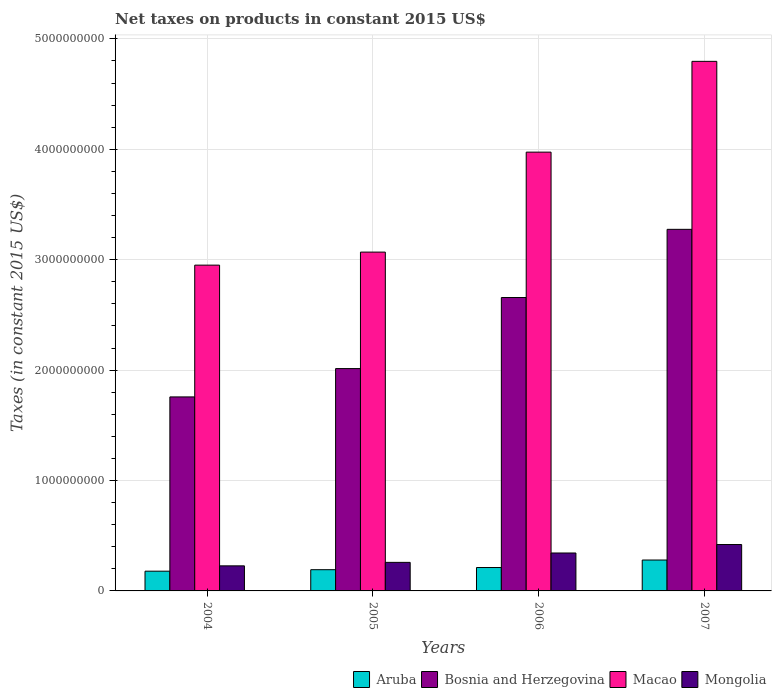How many bars are there on the 1st tick from the left?
Provide a short and direct response. 4. How many bars are there on the 4th tick from the right?
Ensure brevity in your answer.  4. What is the label of the 2nd group of bars from the left?
Your answer should be very brief. 2005. What is the net taxes on products in Macao in 2007?
Ensure brevity in your answer.  4.80e+09. Across all years, what is the maximum net taxes on products in Macao?
Offer a very short reply. 4.80e+09. Across all years, what is the minimum net taxes on products in Mongolia?
Provide a short and direct response. 2.27e+08. In which year was the net taxes on products in Mongolia maximum?
Your answer should be compact. 2007. What is the total net taxes on products in Aruba in the graph?
Provide a succinct answer. 8.63e+08. What is the difference between the net taxes on products in Aruba in 2004 and that in 2005?
Offer a terse response. -1.34e+07. What is the difference between the net taxes on products in Aruba in 2005 and the net taxes on products in Mongolia in 2006?
Give a very brief answer. -1.51e+08. What is the average net taxes on products in Macao per year?
Make the answer very short. 3.70e+09. In the year 2005, what is the difference between the net taxes on products in Mongolia and net taxes on products in Macao?
Offer a very short reply. -2.81e+09. In how many years, is the net taxes on products in Bosnia and Herzegovina greater than 1400000000 US$?
Provide a short and direct response. 4. What is the ratio of the net taxes on products in Bosnia and Herzegovina in 2005 to that in 2007?
Your response must be concise. 0.61. What is the difference between the highest and the second highest net taxes on products in Aruba?
Offer a terse response. 6.79e+07. What is the difference between the highest and the lowest net taxes on products in Bosnia and Herzegovina?
Offer a very short reply. 1.52e+09. Is it the case that in every year, the sum of the net taxes on products in Bosnia and Herzegovina and net taxes on products in Aruba is greater than the sum of net taxes on products in Macao and net taxes on products in Mongolia?
Ensure brevity in your answer.  No. What does the 3rd bar from the left in 2006 represents?
Make the answer very short. Macao. What does the 2nd bar from the right in 2006 represents?
Your answer should be compact. Macao. Does the graph contain any zero values?
Your response must be concise. No. Does the graph contain grids?
Ensure brevity in your answer.  Yes. How many legend labels are there?
Ensure brevity in your answer.  4. How are the legend labels stacked?
Your answer should be very brief. Horizontal. What is the title of the graph?
Your answer should be very brief. Net taxes on products in constant 2015 US$. What is the label or title of the X-axis?
Offer a very short reply. Years. What is the label or title of the Y-axis?
Give a very brief answer. Taxes (in constant 2015 US$). What is the Taxes (in constant 2015 US$) of Aruba in 2004?
Offer a very short reply. 1.79e+08. What is the Taxes (in constant 2015 US$) in Bosnia and Herzegovina in 2004?
Provide a short and direct response. 1.76e+09. What is the Taxes (in constant 2015 US$) of Macao in 2004?
Ensure brevity in your answer.  2.95e+09. What is the Taxes (in constant 2015 US$) of Mongolia in 2004?
Provide a succinct answer. 2.27e+08. What is the Taxes (in constant 2015 US$) in Aruba in 2005?
Ensure brevity in your answer.  1.92e+08. What is the Taxes (in constant 2015 US$) in Bosnia and Herzegovina in 2005?
Ensure brevity in your answer.  2.01e+09. What is the Taxes (in constant 2015 US$) in Macao in 2005?
Give a very brief answer. 3.07e+09. What is the Taxes (in constant 2015 US$) of Mongolia in 2005?
Your answer should be compact. 2.59e+08. What is the Taxes (in constant 2015 US$) in Aruba in 2006?
Give a very brief answer. 2.12e+08. What is the Taxes (in constant 2015 US$) of Bosnia and Herzegovina in 2006?
Keep it short and to the point. 2.66e+09. What is the Taxes (in constant 2015 US$) of Macao in 2006?
Provide a short and direct response. 3.97e+09. What is the Taxes (in constant 2015 US$) in Mongolia in 2006?
Provide a succinct answer. 3.44e+08. What is the Taxes (in constant 2015 US$) in Aruba in 2007?
Make the answer very short. 2.80e+08. What is the Taxes (in constant 2015 US$) in Bosnia and Herzegovina in 2007?
Provide a succinct answer. 3.28e+09. What is the Taxes (in constant 2015 US$) of Macao in 2007?
Provide a succinct answer. 4.80e+09. What is the Taxes (in constant 2015 US$) of Mongolia in 2007?
Offer a very short reply. 4.20e+08. Across all years, what is the maximum Taxes (in constant 2015 US$) of Aruba?
Offer a very short reply. 2.80e+08. Across all years, what is the maximum Taxes (in constant 2015 US$) of Bosnia and Herzegovina?
Give a very brief answer. 3.28e+09. Across all years, what is the maximum Taxes (in constant 2015 US$) in Macao?
Keep it short and to the point. 4.80e+09. Across all years, what is the maximum Taxes (in constant 2015 US$) of Mongolia?
Provide a succinct answer. 4.20e+08. Across all years, what is the minimum Taxes (in constant 2015 US$) of Aruba?
Give a very brief answer. 1.79e+08. Across all years, what is the minimum Taxes (in constant 2015 US$) of Bosnia and Herzegovina?
Provide a short and direct response. 1.76e+09. Across all years, what is the minimum Taxes (in constant 2015 US$) of Macao?
Offer a very short reply. 2.95e+09. Across all years, what is the minimum Taxes (in constant 2015 US$) in Mongolia?
Your answer should be compact. 2.27e+08. What is the total Taxes (in constant 2015 US$) of Aruba in the graph?
Provide a succinct answer. 8.63e+08. What is the total Taxes (in constant 2015 US$) in Bosnia and Herzegovina in the graph?
Ensure brevity in your answer.  9.70e+09. What is the total Taxes (in constant 2015 US$) of Macao in the graph?
Give a very brief answer. 1.48e+1. What is the total Taxes (in constant 2015 US$) of Mongolia in the graph?
Your answer should be very brief. 1.25e+09. What is the difference between the Taxes (in constant 2015 US$) of Aruba in 2004 and that in 2005?
Provide a succinct answer. -1.34e+07. What is the difference between the Taxes (in constant 2015 US$) in Bosnia and Herzegovina in 2004 and that in 2005?
Provide a short and direct response. -2.57e+08. What is the difference between the Taxes (in constant 2015 US$) in Macao in 2004 and that in 2005?
Your response must be concise. -1.18e+08. What is the difference between the Taxes (in constant 2015 US$) in Mongolia in 2004 and that in 2005?
Your answer should be very brief. -3.15e+07. What is the difference between the Taxes (in constant 2015 US$) in Aruba in 2004 and that in 2006?
Make the answer very short. -3.31e+07. What is the difference between the Taxes (in constant 2015 US$) in Bosnia and Herzegovina in 2004 and that in 2006?
Make the answer very short. -9.00e+08. What is the difference between the Taxes (in constant 2015 US$) in Macao in 2004 and that in 2006?
Keep it short and to the point. -1.02e+09. What is the difference between the Taxes (in constant 2015 US$) in Mongolia in 2004 and that in 2006?
Offer a terse response. -1.16e+08. What is the difference between the Taxes (in constant 2015 US$) in Aruba in 2004 and that in 2007?
Offer a terse response. -1.01e+08. What is the difference between the Taxes (in constant 2015 US$) in Bosnia and Herzegovina in 2004 and that in 2007?
Keep it short and to the point. -1.52e+09. What is the difference between the Taxes (in constant 2015 US$) of Macao in 2004 and that in 2007?
Your answer should be very brief. -1.85e+09. What is the difference between the Taxes (in constant 2015 US$) in Mongolia in 2004 and that in 2007?
Ensure brevity in your answer.  -1.93e+08. What is the difference between the Taxes (in constant 2015 US$) in Aruba in 2005 and that in 2006?
Provide a succinct answer. -1.97e+07. What is the difference between the Taxes (in constant 2015 US$) in Bosnia and Herzegovina in 2005 and that in 2006?
Offer a terse response. -6.44e+08. What is the difference between the Taxes (in constant 2015 US$) in Macao in 2005 and that in 2006?
Ensure brevity in your answer.  -9.06e+08. What is the difference between the Taxes (in constant 2015 US$) in Mongolia in 2005 and that in 2006?
Keep it short and to the point. -8.49e+07. What is the difference between the Taxes (in constant 2015 US$) of Aruba in 2005 and that in 2007?
Your answer should be very brief. -8.76e+07. What is the difference between the Taxes (in constant 2015 US$) in Bosnia and Herzegovina in 2005 and that in 2007?
Offer a terse response. -1.26e+09. What is the difference between the Taxes (in constant 2015 US$) in Macao in 2005 and that in 2007?
Provide a short and direct response. -1.73e+09. What is the difference between the Taxes (in constant 2015 US$) of Mongolia in 2005 and that in 2007?
Give a very brief answer. -1.62e+08. What is the difference between the Taxes (in constant 2015 US$) of Aruba in 2006 and that in 2007?
Offer a terse response. -6.79e+07. What is the difference between the Taxes (in constant 2015 US$) of Bosnia and Herzegovina in 2006 and that in 2007?
Provide a short and direct response. -6.18e+08. What is the difference between the Taxes (in constant 2015 US$) of Macao in 2006 and that in 2007?
Ensure brevity in your answer.  -8.22e+08. What is the difference between the Taxes (in constant 2015 US$) of Mongolia in 2006 and that in 2007?
Keep it short and to the point. -7.67e+07. What is the difference between the Taxes (in constant 2015 US$) in Aruba in 2004 and the Taxes (in constant 2015 US$) in Bosnia and Herzegovina in 2005?
Your answer should be compact. -1.84e+09. What is the difference between the Taxes (in constant 2015 US$) in Aruba in 2004 and the Taxes (in constant 2015 US$) in Macao in 2005?
Your answer should be compact. -2.89e+09. What is the difference between the Taxes (in constant 2015 US$) in Aruba in 2004 and the Taxes (in constant 2015 US$) in Mongolia in 2005?
Provide a succinct answer. -7.99e+07. What is the difference between the Taxes (in constant 2015 US$) of Bosnia and Herzegovina in 2004 and the Taxes (in constant 2015 US$) of Macao in 2005?
Give a very brief answer. -1.31e+09. What is the difference between the Taxes (in constant 2015 US$) in Bosnia and Herzegovina in 2004 and the Taxes (in constant 2015 US$) in Mongolia in 2005?
Offer a terse response. 1.50e+09. What is the difference between the Taxes (in constant 2015 US$) of Macao in 2004 and the Taxes (in constant 2015 US$) of Mongolia in 2005?
Make the answer very short. 2.69e+09. What is the difference between the Taxes (in constant 2015 US$) of Aruba in 2004 and the Taxes (in constant 2015 US$) of Bosnia and Herzegovina in 2006?
Keep it short and to the point. -2.48e+09. What is the difference between the Taxes (in constant 2015 US$) of Aruba in 2004 and the Taxes (in constant 2015 US$) of Macao in 2006?
Keep it short and to the point. -3.80e+09. What is the difference between the Taxes (in constant 2015 US$) in Aruba in 2004 and the Taxes (in constant 2015 US$) in Mongolia in 2006?
Keep it short and to the point. -1.65e+08. What is the difference between the Taxes (in constant 2015 US$) of Bosnia and Herzegovina in 2004 and the Taxes (in constant 2015 US$) of Macao in 2006?
Your response must be concise. -2.22e+09. What is the difference between the Taxes (in constant 2015 US$) of Bosnia and Herzegovina in 2004 and the Taxes (in constant 2015 US$) of Mongolia in 2006?
Keep it short and to the point. 1.41e+09. What is the difference between the Taxes (in constant 2015 US$) of Macao in 2004 and the Taxes (in constant 2015 US$) of Mongolia in 2006?
Make the answer very short. 2.61e+09. What is the difference between the Taxes (in constant 2015 US$) of Aruba in 2004 and the Taxes (in constant 2015 US$) of Bosnia and Herzegovina in 2007?
Give a very brief answer. -3.10e+09. What is the difference between the Taxes (in constant 2015 US$) in Aruba in 2004 and the Taxes (in constant 2015 US$) in Macao in 2007?
Make the answer very short. -4.62e+09. What is the difference between the Taxes (in constant 2015 US$) of Aruba in 2004 and the Taxes (in constant 2015 US$) of Mongolia in 2007?
Provide a succinct answer. -2.41e+08. What is the difference between the Taxes (in constant 2015 US$) in Bosnia and Herzegovina in 2004 and the Taxes (in constant 2015 US$) in Macao in 2007?
Offer a terse response. -3.04e+09. What is the difference between the Taxes (in constant 2015 US$) of Bosnia and Herzegovina in 2004 and the Taxes (in constant 2015 US$) of Mongolia in 2007?
Give a very brief answer. 1.34e+09. What is the difference between the Taxes (in constant 2015 US$) in Macao in 2004 and the Taxes (in constant 2015 US$) in Mongolia in 2007?
Your answer should be compact. 2.53e+09. What is the difference between the Taxes (in constant 2015 US$) of Aruba in 2005 and the Taxes (in constant 2015 US$) of Bosnia and Herzegovina in 2006?
Your answer should be very brief. -2.47e+09. What is the difference between the Taxes (in constant 2015 US$) of Aruba in 2005 and the Taxes (in constant 2015 US$) of Macao in 2006?
Your answer should be compact. -3.78e+09. What is the difference between the Taxes (in constant 2015 US$) of Aruba in 2005 and the Taxes (in constant 2015 US$) of Mongolia in 2006?
Offer a terse response. -1.51e+08. What is the difference between the Taxes (in constant 2015 US$) in Bosnia and Herzegovina in 2005 and the Taxes (in constant 2015 US$) in Macao in 2006?
Keep it short and to the point. -1.96e+09. What is the difference between the Taxes (in constant 2015 US$) of Bosnia and Herzegovina in 2005 and the Taxes (in constant 2015 US$) of Mongolia in 2006?
Offer a terse response. 1.67e+09. What is the difference between the Taxes (in constant 2015 US$) of Macao in 2005 and the Taxes (in constant 2015 US$) of Mongolia in 2006?
Offer a terse response. 2.73e+09. What is the difference between the Taxes (in constant 2015 US$) of Aruba in 2005 and the Taxes (in constant 2015 US$) of Bosnia and Herzegovina in 2007?
Give a very brief answer. -3.08e+09. What is the difference between the Taxes (in constant 2015 US$) of Aruba in 2005 and the Taxes (in constant 2015 US$) of Macao in 2007?
Keep it short and to the point. -4.60e+09. What is the difference between the Taxes (in constant 2015 US$) in Aruba in 2005 and the Taxes (in constant 2015 US$) in Mongolia in 2007?
Your response must be concise. -2.28e+08. What is the difference between the Taxes (in constant 2015 US$) in Bosnia and Herzegovina in 2005 and the Taxes (in constant 2015 US$) in Macao in 2007?
Your answer should be compact. -2.78e+09. What is the difference between the Taxes (in constant 2015 US$) of Bosnia and Herzegovina in 2005 and the Taxes (in constant 2015 US$) of Mongolia in 2007?
Provide a succinct answer. 1.59e+09. What is the difference between the Taxes (in constant 2015 US$) of Macao in 2005 and the Taxes (in constant 2015 US$) of Mongolia in 2007?
Your answer should be compact. 2.65e+09. What is the difference between the Taxes (in constant 2015 US$) in Aruba in 2006 and the Taxes (in constant 2015 US$) in Bosnia and Herzegovina in 2007?
Give a very brief answer. -3.06e+09. What is the difference between the Taxes (in constant 2015 US$) of Aruba in 2006 and the Taxes (in constant 2015 US$) of Macao in 2007?
Provide a short and direct response. -4.58e+09. What is the difference between the Taxes (in constant 2015 US$) in Aruba in 2006 and the Taxes (in constant 2015 US$) in Mongolia in 2007?
Ensure brevity in your answer.  -2.08e+08. What is the difference between the Taxes (in constant 2015 US$) of Bosnia and Herzegovina in 2006 and the Taxes (in constant 2015 US$) of Macao in 2007?
Your response must be concise. -2.14e+09. What is the difference between the Taxes (in constant 2015 US$) in Bosnia and Herzegovina in 2006 and the Taxes (in constant 2015 US$) in Mongolia in 2007?
Ensure brevity in your answer.  2.24e+09. What is the difference between the Taxes (in constant 2015 US$) in Macao in 2006 and the Taxes (in constant 2015 US$) in Mongolia in 2007?
Offer a very short reply. 3.55e+09. What is the average Taxes (in constant 2015 US$) of Aruba per year?
Your answer should be compact. 2.16e+08. What is the average Taxes (in constant 2015 US$) of Bosnia and Herzegovina per year?
Your answer should be compact. 2.43e+09. What is the average Taxes (in constant 2015 US$) of Macao per year?
Keep it short and to the point. 3.70e+09. What is the average Taxes (in constant 2015 US$) in Mongolia per year?
Your response must be concise. 3.12e+08. In the year 2004, what is the difference between the Taxes (in constant 2015 US$) in Aruba and Taxes (in constant 2015 US$) in Bosnia and Herzegovina?
Provide a succinct answer. -1.58e+09. In the year 2004, what is the difference between the Taxes (in constant 2015 US$) of Aruba and Taxes (in constant 2015 US$) of Macao?
Keep it short and to the point. -2.77e+09. In the year 2004, what is the difference between the Taxes (in constant 2015 US$) of Aruba and Taxes (in constant 2015 US$) of Mongolia?
Keep it short and to the point. -4.83e+07. In the year 2004, what is the difference between the Taxes (in constant 2015 US$) of Bosnia and Herzegovina and Taxes (in constant 2015 US$) of Macao?
Offer a terse response. -1.19e+09. In the year 2004, what is the difference between the Taxes (in constant 2015 US$) in Bosnia and Herzegovina and Taxes (in constant 2015 US$) in Mongolia?
Your answer should be very brief. 1.53e+09. In the year 2004, what is the difference between the Taxes (in constant 2015 US$) in Macao and Taxes (in constant 2015 US$) in Mongolia?
Provide a succinct answer. 2.72e+09. In the year 2005, what is the difference between the Taxes (in constant 2015 US$) in Aruba and Taxes (in constant 2015 US$) in Bosnia and Herzegovina?
Provide a short and direct response. -1.82e+09. In the year 2005, what is the difference between the Taxes (in constant 2015 US$) in Aruba and Taxes (in constant 2015 US$) in Macao?
Offer a very short reply. -2.88e+09. In the year 2005, what is the difference between the Taxes (in constant 2015 US$) in Aruba and Taxes (in constant 2015 US$) in Mongolia?
Offer a very short reply. -6.64e+07. In the year 2005, what is the difference between the Taxes (in constant 2015 US$) of Bosnia and Herzegovina and Taxes (in constant 2015 US$) of Macao?
Provide a short and direct response. -1.06e+09. In the year 2005, what is the difference between the Taxes (in constant 2015 US$) in Bosnia and Herzegovina and Taxes (in constant 2015 US$) in Mongolia?
Provide a succinct answer. 1.76e+09. In the year 2005, what is the difference between the Taxes (in constant 2015 US$) in Macao and Taxes (in constant 2015 US$) in Mongolia?
Your answer should be very brief. 2.81e+09. In the year 2006, what is the difference between the Taxes (in constant 2015 US$) of Aruba and Taxes (in constant 2015 US$) of Bosnia and Herzegovina?
Make the answer very short. -2.45e+09. In the year 2006, what is the difference between the Taxes (in constant 2015 US$) in Aruba and Taxes (in constant 2015 US$) in Macao?
Your response must be concise. -3.76e+09. In the year 2006, what is the difference between the Taxes (in constant 2015 US$) of Aruba and Taxes (in constant 2015 US$) of Mongolia?
Keep it short and to the point. -1.32e+08. In the year 2006, what is the difference between the Taxes (in constant 2015 US$) of Bosnia and Herzegovina and Taxes (in constant 2015 US$) of Macao?
Offer a very short reply. -1.32e+09. In the year 2006, what is the difference between the Taxes (in constant 2015 US$) of Bosnia and Herzegovina and Taxes (in constant 2015 US$) of Mongolia?
Your answer should be very brief. 2.31e+09. In the year 2006, what is the difference between the Taxes (in constant 2015 US$) in Macao and Taxes (in constant 2015 US$) in Mongolia?
Keep it short and to the point. 3.63e+09. In the year 2007, what is the difference between the Taxes (in constant 2015 US$) in Aruba and Taxes (in constant 2015 US$) in Bosnia and Herzegovina?
Keep it short and to the point. -3.00e+09. In the year 2007, what is the difference between the Taxes (in constant 2015 US$) in Aruba and Taxes (in constant 2015 US$) in Macao?
Your answer should be very brief. -4.52e+09. In the year 2007, what is the difference between the Taxes (in constant 2015 US$) in Aruba and Taxes (in constant 2015 US$) in Mongolia?
Your answer should be compact. -1.40e+08. In the year 2007, what is the difference between the Taxes (in constant 2015 US$) in Bosnia and Herzegovina and Taxes (in constant 2015 US$) in Macao?
Offer a very short reply. -1.52e+09. In the year 2007, what is the difference between the Taxes (in constant 2015 US$) of Bosnia and Herzegovina and Taxes (in constant 2015 US$) of Mongolia?
Your answer should be compact. 2.85e+09. In the year 2007, what is the difference between the Taxes (in constant 2015 US$) in Macao and Taxes (in constant 2015 US$) in Mongolia?
Your response must be concise. 4.38e+09. What is the ratio of the Taxes (in constant 2015 US$) of Aruba in 2004 to that in 2005?
Provide a succinct answer. 0.93. What is the ratio of the Taxes (in constant 2015 US$) of Bosnia and Herzegovina in 2004 to that in 2005?
Keep it short and to the point. 0.87. What is the ratio of the Taxes (in constant 2015 US$) of Macao in 2004 to that in 2005?
Offer a terse response. 0.96. What is the ratio of the Taxes (in constant 2015 US$) in Mongolia in 2004 to that in 2005?
Offer a terse response. 0.88. What is the ratio of the Taxes (in constant 2015 US$) of Aruba in 2004 to that in 2006?
Your answer should be compact. 0.84. What is the ratio of the Taxes (in constant 2015 US$) of Bosnia and Herzegovina in 2004 to that in 2006?
Provide a short and direct response. 0.66. What is the ratio of the Taxes (in constant 2015 US$) of Macao in 2004 to that in 2006?
Provide a succinct answer. 0.74. What is the ratio of the Taxes (in constant 2015 US$) of Mongolia in 2004 to that in 2006?
Keep it short and to the point. 0.66. What is the ratio of the Taxes (in constant 2015 US$) in Aruba in 2004 to that in 2007?
Offer a very short reply. 0.64. What is the ratio of the Taxes (in constant 2015 US$) in Bosnia and Herzegovina in 2004 to that in 2007?
Your response must be concise. 0.54. What is the ratio of the Taxes (in constant 2015 US$) in Macao in 2004 to that in 2007?
Provide a succinct answer. 0.62. What is the ratio of the Taxes (in constant 2015 US$) in Mongolia in 2004 to that in 2007?
Offer a very short reply. 0.54. What is the ratio of the Taxes (in constant 2015 US$) of Aruba in 2005 to that in 2006?
Offer a terse response. 0.91. What is the ratio of the Taxes (in constant 2015 US$) of Bosnia and Herzegovina in 2005 to that in 2006?
Your answer should be compact. 0.76. What is the ratio of the Taxes (in constant 2015 US$) of Macao in 2005 to that in 2006?
Offer a terse response. 0.77. What is the ratio of the Taxes (in constant 2015 US$) in Mongolia in 2005 to that in 2006?
Make the answer very short. 0.75. What is the ratio of the Taxes (in constant 2015 US$) in Aruba in 2005 to that in 2007?
Ensure brevity in your answer.  0.69. What is the ratio of the Taxes (in constant 2015 US$) of Bosnia and Herzegovina in 2005 to that in 2007?
Give a very brief answer. 0.61. What is the ratio of the Taxes (in constant 2015 US$) in Macao in 2005 to that in 2007?
Keep it short and to the point. 0.64. What is the ratio of the Taxes (in constant 2015 US$) in Mongolia in 2005 to that in 2007?
Provide a succinct answer. 0.62. What is the ratio of the Taxes (in constant 2015 US$) of Aruba in 2006 to that in 2007?
Provide a succinct answer. 0.76. What is the ratio of the Taxes (in constant 2015 US$) in Bosnia and Herzegovina in 2006 to that in 2007?
Keep it short and to the point. 0.81. What is the ratio of the Taxes (in constant 2015 US$) of Macao in 2006 to that in 2007?
Make the answer very short. 0.83. What is the ratio of the Taxes (in constant 2015 US$) of Mongolia in 2006 to that in 2007?
Make the answer very short. 0.82. What is the difference between the highest and the second highest Taxes (in constant 2015 US$) of Aruba?
Offer a very short reply. 6.79e+07. What is the difference between the highest and the second highest Taxes (in constant 2015 US$) in Bosnia and Herzegovina?
Your response must be concise. 6.18e+08. What is the difference between the highest and the second highest Taxes (in constant 2015 US$) in Macao?
Provide a short and direct response. 8.22e+08. What is the difference between the highest and the second highest Taxes (in constant 2015 US$) of Mongolia?
Offer a terse response. 7.67e+07. What is the difference between the highest and the lowest Taxes (in constant 2015 US$) of Aruba?
Provide a succinct answer. 1.01e+08. What is the difference between the highest and the lowest Taxes (in constant 2015 US$) of Bosnia and Herzegovina?
Your answer should be compact. 1.52e+09. What is the difference between the highest and the lowest Taxes (in constant 2015 US$) in Macao?
Make the answer very short. 1.85e+09. What is the difference between the highest and the lowest Taxes (in constant 2015 US$) in Mongolia?
Offer a terse response. 1.93e+08. 